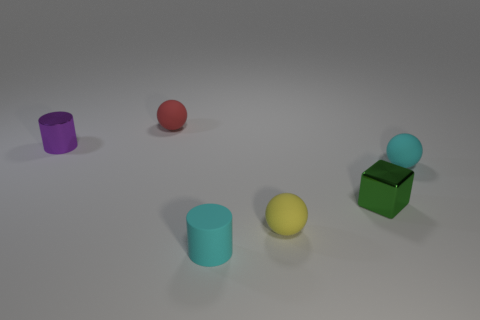What number of objects are on the left side of the red rubber object and on the right side of the tiny yellow thing?
Give a very brief answer. 0. There is a tiny cyan rubber object in front of the cube; is its shape the same as the tiny purple thing?
Ensure brevity in your answer.  Yes. What is the material of the green block that is the same size as the purple metallic cylinder?
Ensure brevity in your answer.  Metal. Are there an equal number of cyan spheres behind the red matte object and small rubber things in front of the small metal cube?
Keep it short and to the point. No. There is a small thing on the left side of the rubber thing behind the cyan rubber sphere; how many objects are in front of it?
Provide a short and direct response. 4. There is a small matte cylinder; is it the same color as the matte sphere to the right of the tiny green metallic cube?
Offer a terse response. Yes. There is a cyan cylinder that is the same material as the tiny yellow thing; what size is it?
Provide a short and direct response. Small. Is the number of objects that are left of the tiny green thing greater than the number of green metal blocks?
Offer a terse response. Yes. What material is the small ball to the right of the shiny object that is to the right of the small cylinder that is to the right of the red rubber object?
Your answer should be very brief. Rubber. Are the cyan cylinder and the cylinder behind the rubber cylinder made of the same material?
Your answer should be compact. No. 